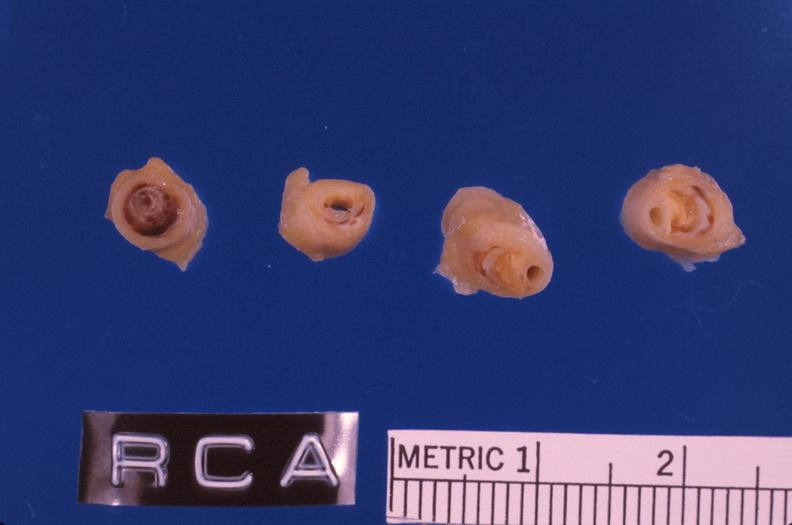does atrophy show coronary artery atherosclerosis?
Answer the question using a single word or phrase. No 